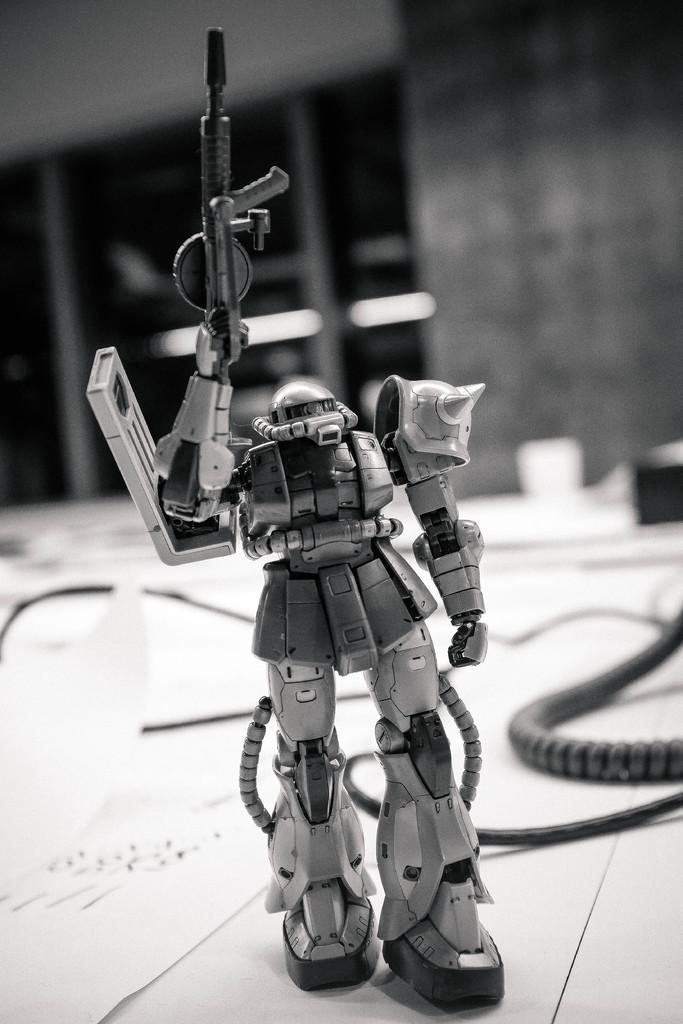Could you give a brief overview of what you see in this image? This is a black and white image where we can see a robot toy at the bottom of this image, and it seems like there is a wall in the background. 